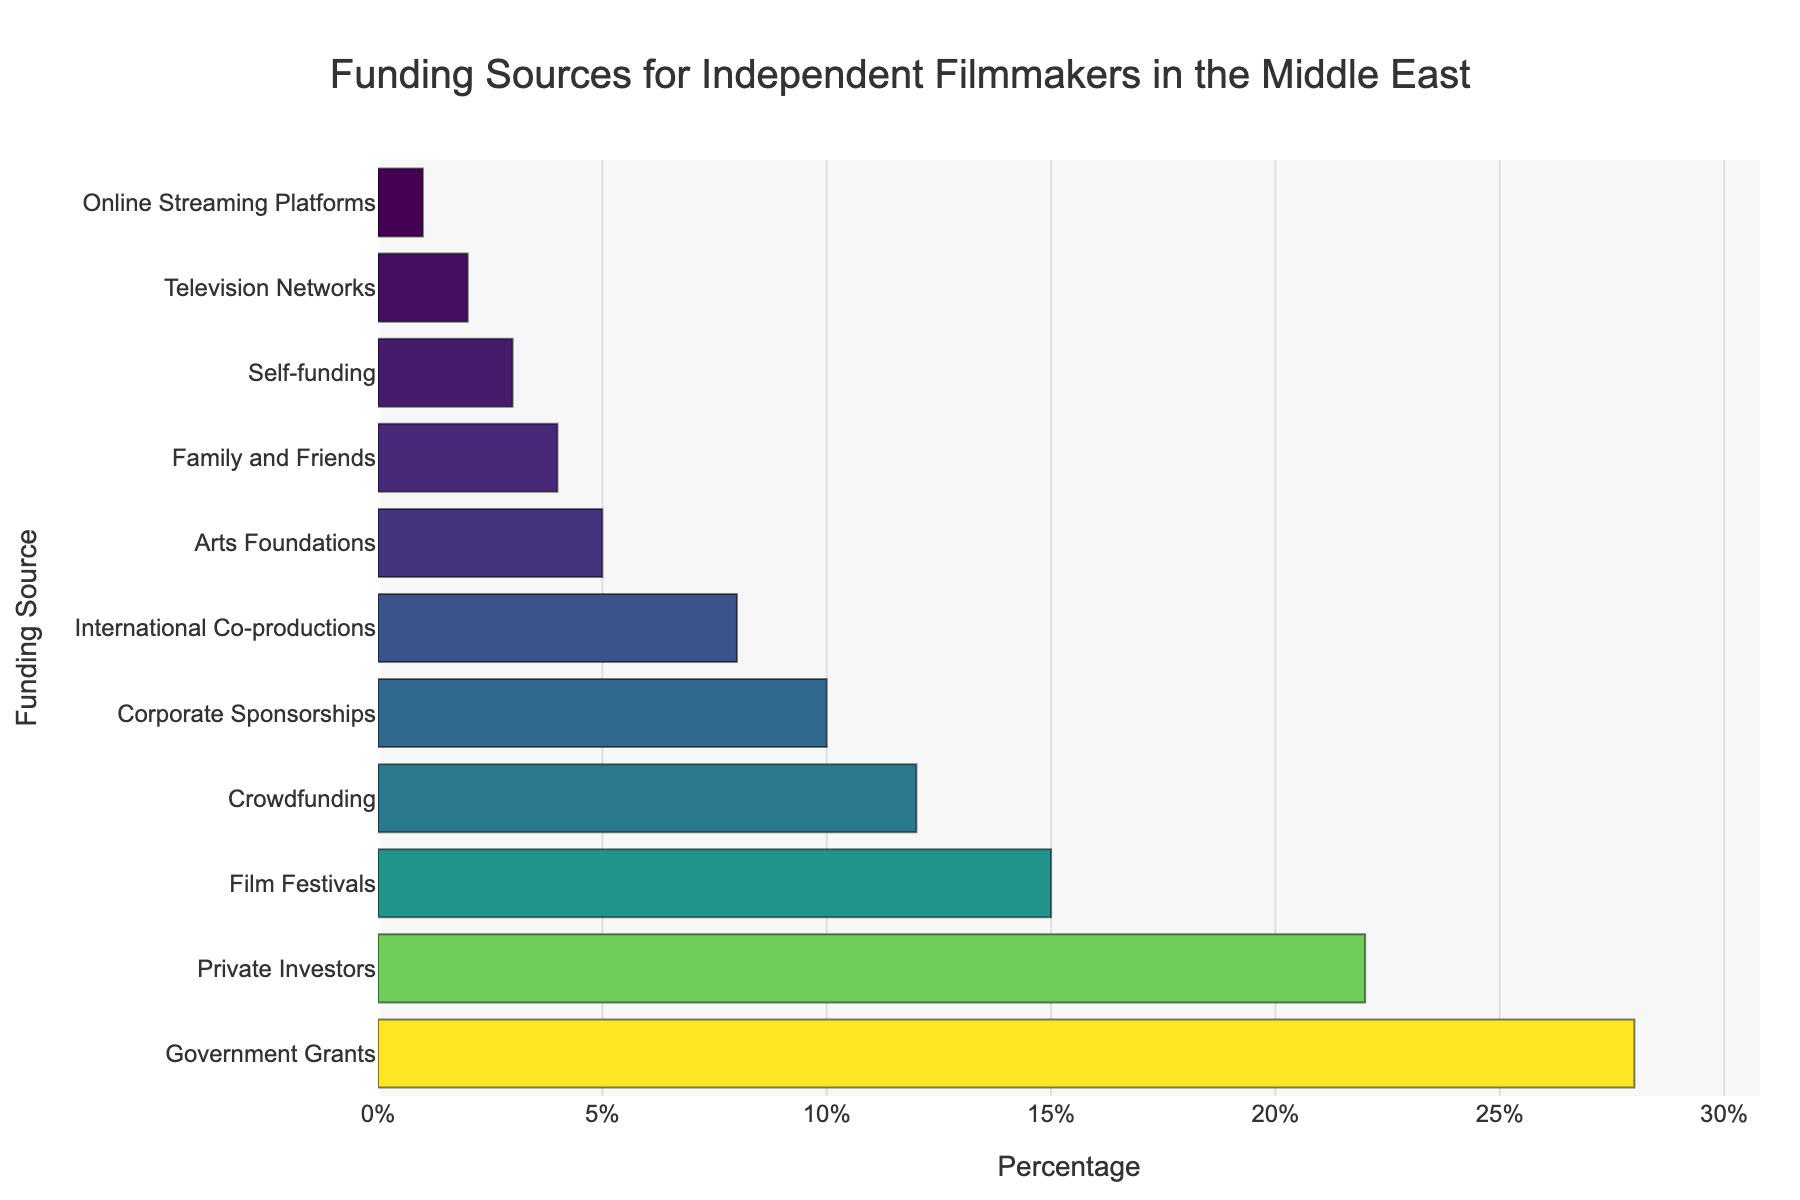Which funding source has the highest percentage? The bar chart shows the percentages of different funding sources, with the bar for Government Grants being the longest.
Answer: Government Grants What is the combined percentage of Crowdfunding, Corporate Sponsorships, and International Co-productions? Add the percentages of Crowdfunding (12%), Corporate Sponsorships (10%), and International Co-productions (8%): 12 + 10 + 8 = 30%
Answer: 30% Which funding source has a lower percentage, Private Investors or Film Festivals? Compare the lengths of the bars for Private Investors and Film Festivals. Film Festivals' percentage is 15%, while Private Investors' percentage is 22%.
Answer: Film Festivals How much higher is the percentage of Government Grants compared to Arts Foundations? Subtract the percentage of Arts Foundations (5%) from Government Grants (28%): 28 - 5 = 23%
Answer: 23% What percentage of funding comes from sources with less than 10% each? Add the percentages for sources contributing less than 10%: International Co-productions (8%), Arts Foundations (5%), Family and Friends (4%), Self-funding (3%), Television Networks (2%), Online Streaming Platforms (1%): 8 + 5 + 4 + 3 + 2 + 1 = 23%
Answer: 23% Which funding source contributes just slightly less than Crowdfunding? Look for the bar just below Crowdfunding (12%); Corporate Sponsorships contributes 10%.
Answer: Corporate Sponsorships Are there more funding sources with percentages above 10% or below 10%? Count the bars with percentages above 10%: Government Grants, Private Investors, Film Festivals, Crowdfunding, and Corporate Sponsorships (5), and those below 10%: International Co-productions, Arts Foundations, Family and Friends, Self-funding, Television Networks, Online Streaming Platforms (6).
Answer: Below 10% What's the average percentage of the top three funding sources? Add the percentages of the top three funding sources: Government Grants (28%), Private Investors (22%), Film Festivals (15%): (28 + 22 + 15) / 3 = 65 / 3 ≈ 21.67%
Answer: 21.67% Among the bottom five funding sources, which one has the highest percentage? Inspect the last five bars: Arts Foundations (5%), Family and Friends (4%), Self-funding (3%), Television Networks (2%), Online Streaming Platforms (1%). Arts Foundations has the highest percentage.
Answer: Arts Foundations 